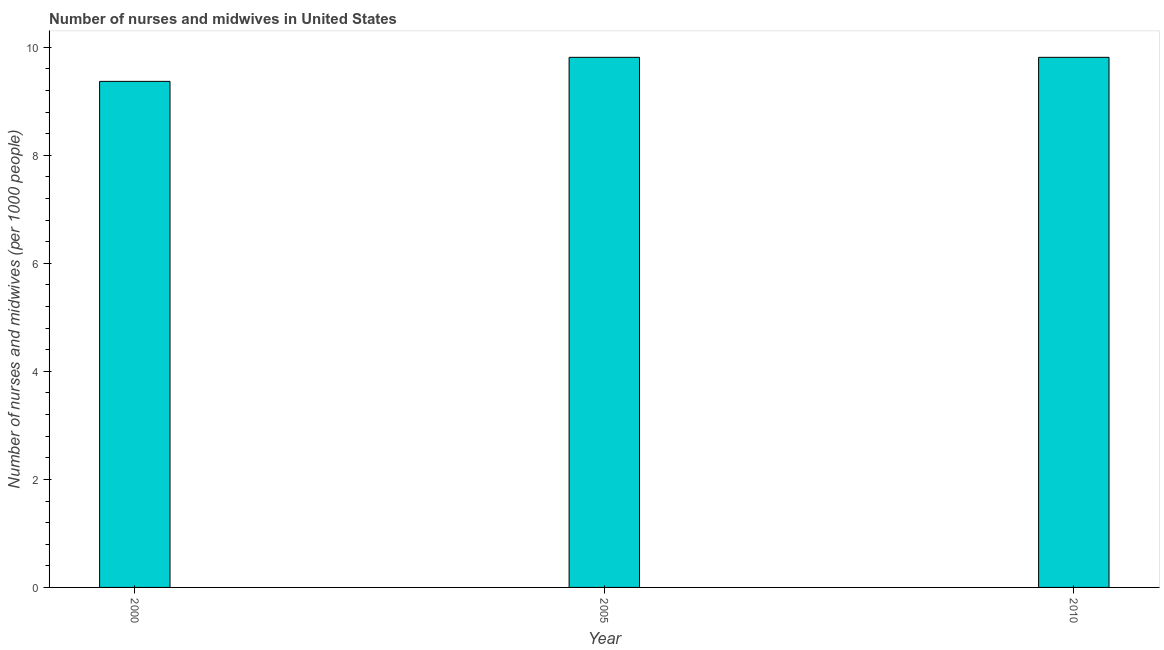Does the graph contain any zero values?
Provide a short and direct response. No. What is the title of the graph?
Offer a very short reply. Number of nurses and midwives in United States. What is the label or title of the Y-axis?
Provide a succinct answer. Number of nurses and midwives (per 1000 people). What is the number of nurses and midwives in 2000?
Keep it short and to the point. 9.37. Across all years, what is the maximum number of nurses and midwives?
Keep it short and to the point. 9.81. Across all years, what is the minimum number of nurses and midwives?
Provide a succinct answer. 9.37. In which year was the number of nurses and midwives maximum?
Make the answer very short. 2005. What is the difference between the number of nurses and midwives in 2000 and 2010?
Provide a succinct answer. -0.45. What is the average number of nurses and midwives per year?
Your response must be concise. 9.67. What is the median number of nurses and midwives?
Your answer should be very brief. 9.81. Do a majority of the years between 2010 and 2005 (inclusive) have number of nurses and midwives greater than 4.8 ?
Keep it short and to the point. No. Is the number of nurses and midwives in 2005 less than that in 2010?
Your answer should be very brief. No. Is the difference between the number of nurses and midwives in 2005 and 2010 greater than the difference between any two years?
Offer a very short reply. No. What is the difference between the highest and the lowest number of nurses and midwives?
Your response must be concise. 0.45. In how many years, is the number of nurses and midwives greater than the average number of nurses and midwives taken over all years?
Your answer should be very brief. 2. What is the difference between two consecutive major ticks on the Y-axis?
Provide a succinct answer. 2. What is the Number of nurses and midwives (per 1000 people) of 2000?
Your answer should be very brief. 9.37. What is the Number of nurses and midwives (per 1000 people) in 2005?
Keep it short and to the point. 9.81. What is the Number of nurses and midwives (per 1000 people) of 2010?
Offer a terse response. 9.81. What is the difference between the Number of nurses and midwives (per 1000 people) in 2000 and 2005?
Offer a terse response. -0.45. What is the difference between the Number of nurses and midwives (per 1000 people) in 2000 and 2010?
Give a very brief answer. -0.45. What is the difference between the Number of nurses and midwives (per 1000 people) in 2005 and 2010?
Offer a terse response. 0. What is the ratio of the Number of nurses and midwives (per 1000 people) in 2000 to that in 2005?
Provide a succinct answer. 0.95. What is the ratio of the Number of nurses and midwives (per 1000 people) in 2000 to that in 2010?
Provide a succinct answer. 0.95. What is the ratio of the Number of nurses and midwives (per 1000 people) in 2005 to that in 2010?
Keep it short and to the point. 1. 